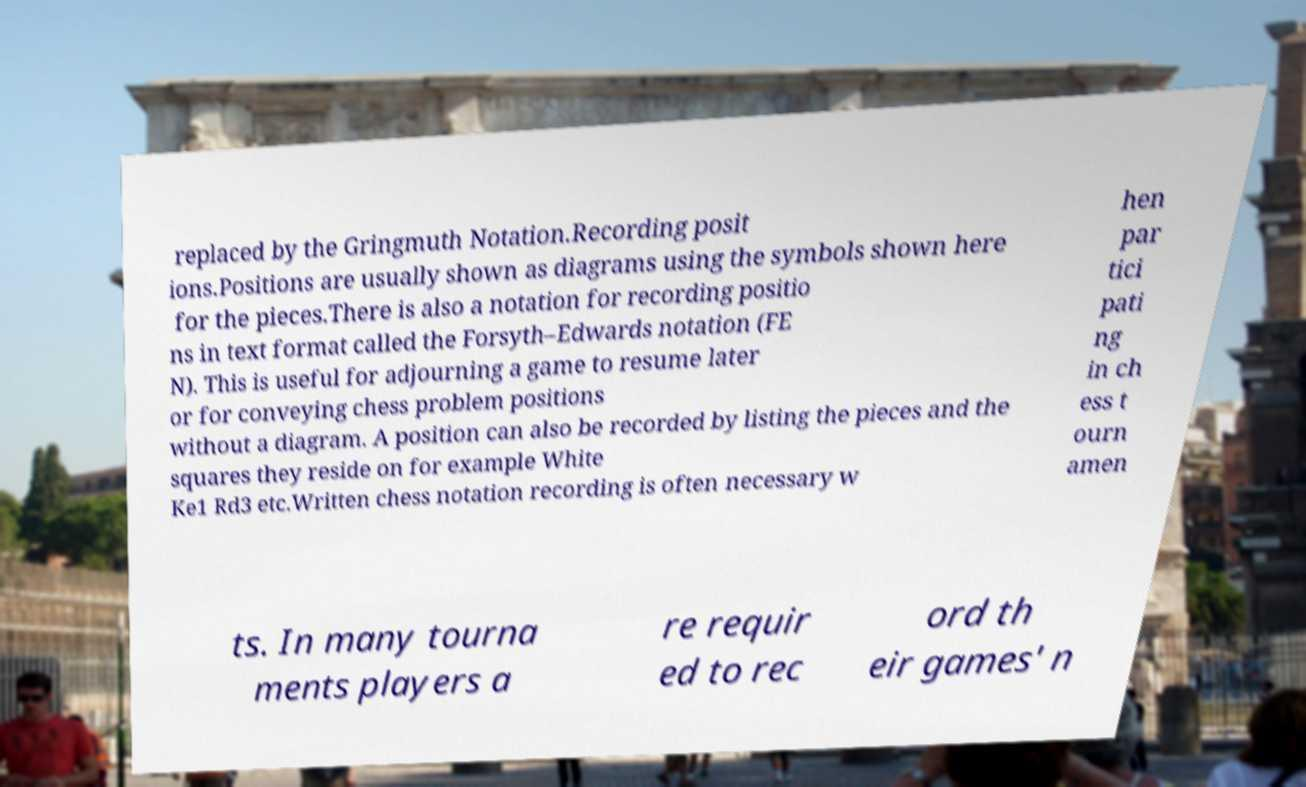I need the written content from this picture converted into text. Can you do that? replaced by the Gringmuth Notation.Recording posit ions.Positions are usually shown as diagrams using the symbols shown here for the pieces.There is also a notation for recording positio ns in text format called the Forsyth–Edwards notation (FE N). This is useful for adjourning a game to resume later or for conveying chess problem positions without a diagram. A position can also be recorded by listing the pieces and the squares they reside on for example White Ke1 Rd3 etc.Written chess notation recording is often necessary w hen par tici pati ng in ch ess t ourn amen ts. In many tourna ments players a re requir ed to rec ord th eir games' n 